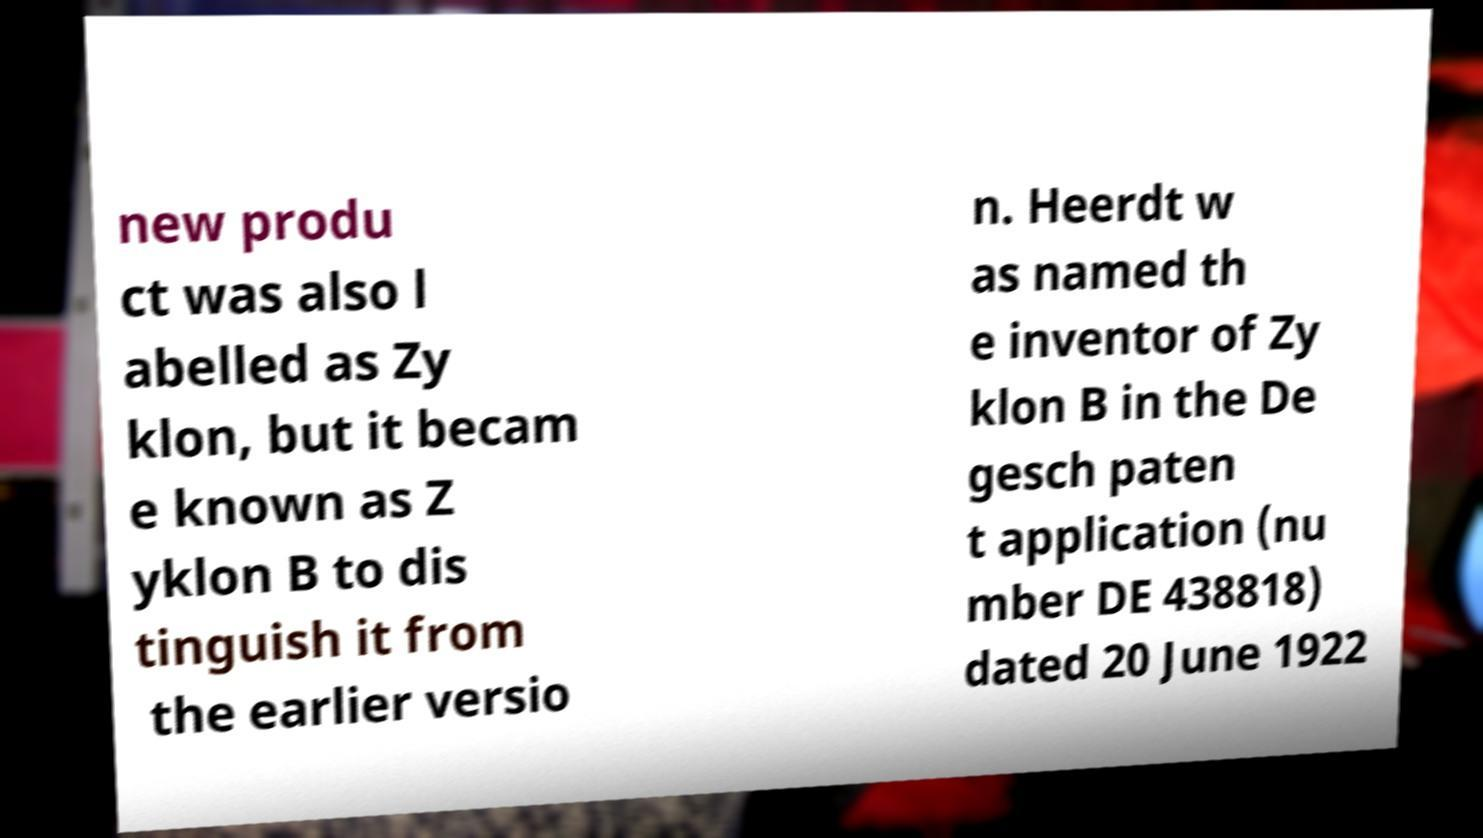There's text embedded in this image that I need extracted. Can you transcribe it verbatim? new produ ct was also l abelled as Zy klon, but it becam e known as Z yklon B to dis tinguish it from the earlier versio n. Heerdt w as named th e inventor of Zy klon B in the De gesch paten t application (nu mber DE 438818) dated 20 June 1922 